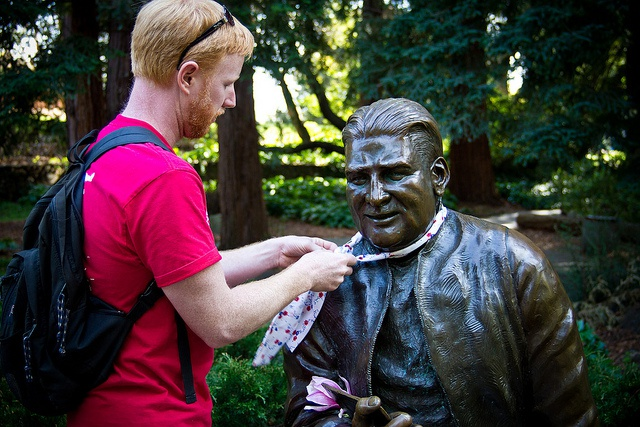Describe the objects in this image and their specific colors. I can see people in black, maroon, and brown tones, backpack in black, navy, blue, and gray tones, and tie in black, darkgray, and lavender tones in this image. 